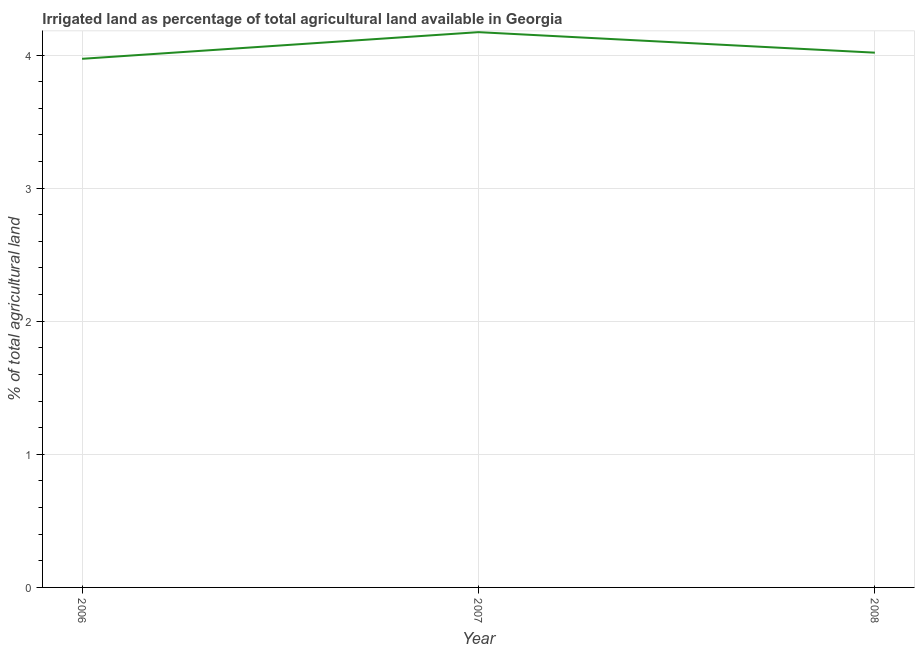What is the percentage of agricultural irrigated land in 2006?
Make the answer very short. 3.97. Across all years, what is the maximum percentage of agricultural irrigated land?
Your answer should be compact. 4.17. Across all years, what is the minimum percentage of agricultural irrigated land?
Make the answer very short. 3.97. In which year was the percentage of agricultural irrigated land maximum?
Your answer should be compact. 2007. In which year was the percentage of agricultural irrigated land minimum?
Your response must be concise. 2006. What is the sum of the percentage of agricultural irrigated land?
Your response must be concise. 12.16. What is the difference between the percentage of agricultural irrigated land in 2006 and 2007?
Provide a succinct answer. -0.2. What is the average percentage of agricultural irrigated land per year?
Your answer should be very brief. 4.05. What is the median percentage of agricultural irrigated land?
Offer a terse response. 4.02. Do a majority of the years between 2006 and 2008 (inclusive) have percentage of agricultural irrigated land greater than 0.8 %?
Your answer should be compact. Yes. What is the ratio of the percentage of agricultural irrigated land in 2006 to that in 2008?
Offer a very short reply. 0.99. Is the percentage of agricultural irrigated land in 2006 less than that in 2008?
Your response must be concise. Yes. What is the difference between the highest and the second highest percentage of agricultural irrigated land?
Keep it short and to the point. 0.15. What is the difference between the highest and the lowest percentage of agricultural irrigated land?
Provide a short and direct response. 0.2. In how many years, is the percentage of agricultural irrigated land greater than the average percentage of agricultural irrigated land taken over all years?
Provide a short and direct response. 1. How many lines are there?
Your answer should be very brief. 1. What is the difference between two consecutive major ticks on the Y-axis?
Ensure brevity in your answer.  1. Are the values on the major ticks of Y-axis written in scientific E-notation?
Your answer should be very brief. No. Does the graph contain any zero values?
Your response must be concise. No. What is the title of the graph?
Offer a very short reply. Irrigated land as percentage of total agricultural land available in Georgia. What is the label or title of the X-axis?
Make the answer very short. Year. What is the label or title of the Y-axis?
Your answer should be compact. % of total agricultural land. What is the % of total agricultural land in 2006?
Make the answer very short. 3.97. What is the % of total agricultural land of 2007?
Your answer should be compact. 4.17. What is the % of total agricultural land of 2008?
Provide a succinct answer. 4.02. What is the difference between the % of total agricultural land in 2006 and 2007?
Provide a succinct answer. -0.2. What is the difference between the % of total agricultural land in 2006 and 2008?
Offer a terse response. -0.05. What is the difference between the % of total agricultural land in 2007 and 2008?
Your answer should be compact. 0.15. What is the ratio of the % of total agricultural land in 2006 to that in 2007?
Your answer should be compact. 0.95. What is the ratio of the % of total agricultural land in 2006 to that in 2008?
Your answer should be compact. 0.99. What is the ratio of the % of total agricultural land in 2007 to that in 2008?
Ensure brevity in your answer.  1.04. 